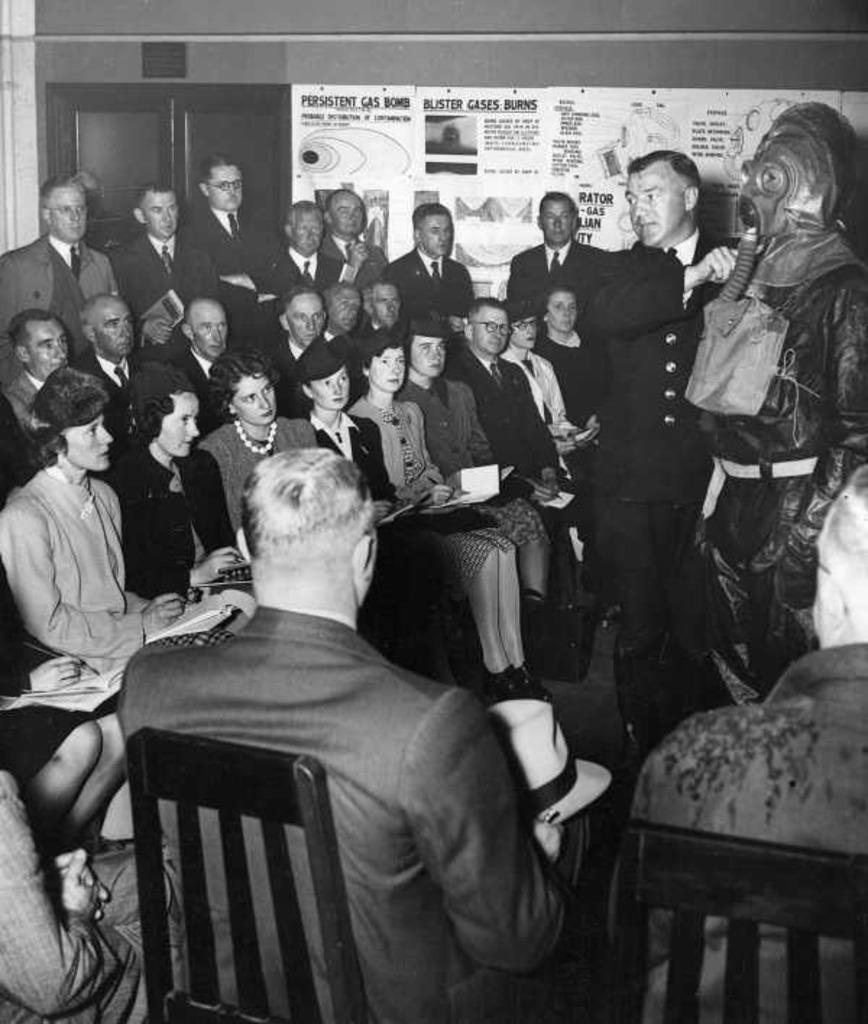How many people are in the image? There is a group of people in the image, but the exact number is not specified. What are the people in the image doing? Some people are sitting, while others are standing. What color is the wall in the image? There is a brown color wall in the image. What is attached to the wall in the image? A banner is attached to the wall. How much income does the basketball player earn in the image? There is no basketball player or mention of income in the image. The image only shows a group of people, a brown wall, and a banner attached to the wall. 